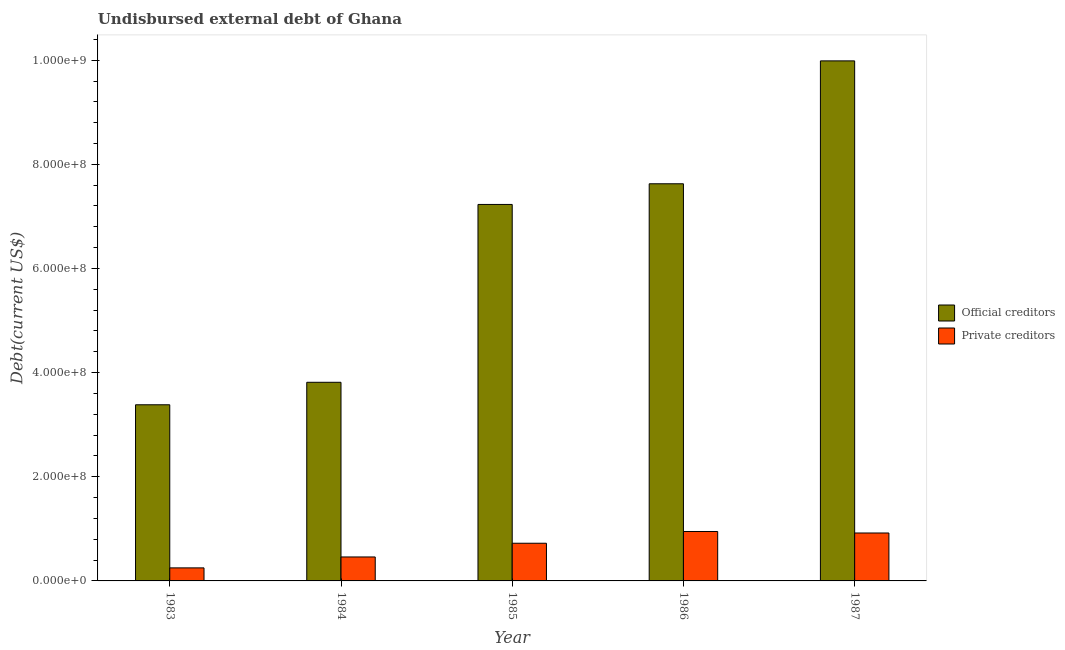How many different coloured bars are there?
Your answer should be very brief. 2. Are the number of bars per tick equal to the number of legend labels?
Give a very brief answer. Yes. Are the number of bars on each tick of the X-axis equal?
Offer a very short reply. Yes. How many bars are there on the 2nd tick from the right?
Your answer should be compact. 2. What is the label of the 4th group of bars from the left?
Your response must be concise. 1986. What is the undisbursed external debt of official creditors in 1987?
Your answer should be compact. 9.99e+08. Across all years, what is the maximum undisbursed external debt of official creditors?
Give a very brief answer. 9.99e+08. Across all years, what is the minimum undisbursed external debt of private creditors?
Your answer should be very brief. 2.50e+07. In which year was the undisbursed external debt of private creditors minimum?
Make the answer very short. 1983. What is the total undisbursed external debt of private creditors in the graph?
Make the answer very short. 3.30e+08. What is the difference between the undisbursed external debt of private creditors in 1984 and that in 1985?
Your answer should be compact. -2.63e+07. What is the difference between the undisbursed external debt of private creditors in 1987 and the undisbursed external debt of official creditors in 1983?
Your answer should be very brief. 6.70e+07. What is the average undisbursed external debt of official creditors per year?
Give a very brief answer. 6.41e+08. In the year 1983, what is the difference between the undisbursed external debt of private creditors and undisbursed external debt of official creditors?
Provide a succinct answer. 0. In how many years, is the undisbursed external debt of private creditors greater than 440000000 US$?
Offer a very short reply. 0. What is the ratio of the undisbursed external debt of private creditors in 1984 to that in 1987?
Offer a terse response. 0.5. Is the undisbursed external debt of private creditors in 1985 less than that in 1987?
Provide a short and direct response. Yes. What is the difference between the highest and the second highest undisbursed external debt of private creditors?
Give a very brief answer. 2.88e+06. What is the difference between the highest and the lowest undisbursed external debt of official creditors?
Your response must be concise. 6.60e+08. What does the 2nd bar from the left in 1983 represents?
Your response must be concise. Private creditors. What does the 1st bar from the right in 1983 represents?
Make the answer very short. Private creditors. How many years are there in the graph?
Your answer should be compact. 5. Does the graph contain any zero values?
Make the answer very short. No. Where does the legend appear in the graph?
Keep it short and to the point. Center right. How many legend labels are there?
Your response must be concise. 2. How are the legend labels stacked?
Your answer should be very brief. Vertical. What is the title of the graph?
Provide a succinct answer. Undisbursed external debt of Ghana. Does "Canada" appear as one of the legend labels in the graph?
Ensure brevity in your answer.  No. What is the label or title of the Y-axis?
Offer a very short reply. Debt(current US$). What is the Debt(current US$) in Official creditors in 1983?
Ensure brevity in your answer.  3.38e+08. What is the Debt(current US$) in Private creditors in 1983?
Keep it short and to the point. 2.50e+07. What is the Debt(current US$) of Official creditors in 1984?
Provide a short and direct response. 3.81e+08. What is the Debt(current US$) of Private creditors in 1984?
Provide a short and direct response. 4.60e+07. What is the Debt(current US$) in Official creditors in 1985?
Provide a short and direct response. 7.23e+08. What is the Debt(current US$) in Private creditors in 1985?
Provide a short and direct response. 7.24e+07. What is the Debt(current US$) in Official creditors in 1986?
Provide a succinct answer. 7.63e+08. What is the Debt(current US$) in Private creditors in 1986?
Your response must be concise. 9.49e+07. What is the Debt(current US$) of Official creditors in 1987?
Your answer should be compact. 9.99e+08. What is the Debt(current US$) of Private creditors in 1987?
Offer a terse response. 9.20e+07. Across all years, what is the maximum Debt(current US$) of Official creditors?
Provide a succinct answer. 9.99e+08. Across all years, what is the maximum Debt(current US$) in Private creditors?
Offer a very short reply. 9.49e+07. Across all years, what is the minimum Debt(current US$) in Official creditors?
Give a very brief answer. 3.38e+08. Across all years, what is the minimum Debt(current US$) of Private creditors?
Your answer should be very brief. 2.50e+07. What is the total Debt(current US$) of Official creditors in the graph?
Give a very brief answer. 3.20e+09. What is the total Debt(current US$) of Private creditors in the graph?
Your answer should be very brief. 3.30e+08. What is the difference between the Debt(current US$) in Official creditors in 1983 and that in 1984?
Provide a short and direct response. -4.32e+07. What is the difference between the Debt(current US$) in Private creditors in 1983 and that in 1984?
Your answer should be compact. -2.10e+07. What is the difference between the Debt(current US$) of Official creditors in 1983 and that in 1985?
Your answer should be very brief. -3.85e+08. What is the difference between the Debt(current US$) of Private creditors in 1983 and that in 1985?
Give a very brief answer. -4.73e+07. What is the difference between the Debt(current US$) of Official creditors in 1983 and that in 1986?
Your answer should be compact. -4.24e+08. What is the difference between the Debt(current US$) of Private creditors in 1983 and that in 1986?
Your response must be concise. -6.99e+07. What is the difference between the Debt(current US$) in Official creditors in 1983 and that in 1987?
Provide a succinct answer. -6.60e+08. What is the difference between the Debt(current US$) of Private creditors in 1983 and that in 1987?
Make the answer very short. -6.70e+07. What is the difference between the Debt(current US$) in Official creditors in 1984 and that in 1985?
Make the answer very short. -3.42e+08. What is the difference between the Debt(current US$) in Private creditors in 1984 and that in 1985?
Provide a short and direct response. -2.63e+07. What is the difference between the Debt(current US$) in Official creditors in 1984 and that in 1986?
Your answer should be compact. -3.81e+08. What is the difference between the Debt(current US$) of Private creditors in 1984 and that in 1986?
Offer a terse response. -4.89e+07. What is the difference between the Debt(current US$) of Official creditors in 1984 and that in 1987?
Offer a terse response. -6.17e+08. What is the difference between the Debt(current US$) of Private creditors in 1984 and that in 1987?
Offer a very short reply. -4.60e+07. What is the difference between the Debt(current US$) in Official creditors in 1985 and that in 1986?
Keep it short and to the point. -3.97e+07. What is the difference between the Debt(current US$) of Private creditors in 1985 and that in 1986?
Ensure brevity in your answer.  -2.26e+07. What is the difference between the Debt(current US$) in Official creditors in 1985 and that in 1987?
Provide a succinct answer. -2.76e+08. What is the difference between the Debt(current US$) in Private creditors in 1985 and that in 1987?
Offer a terse response. -1.97e+07. What is the difference between the Debt(current US$) of Official creditors in 1986 and that in 1987?
Offer a terse response. -2.36e+08. What is the difference between the Debt(current US$) in Private creditors in 1986 and that in 1987?
Keep it short and to the point. 2.88e+06. What is the difference between the Debt(current US$) in Official creditors in 1983 and the Debt(current US$) in Private creditors in 1984?
Provide a succinct answer. 2.92e+08. What is the difference between the Debt(current US$) of Official creditors in 1983 and the Debt(current US$) of Private creditors in 1985?
Your response must be concise. 2.66e+08. What is the difference between the Debt(current US$) of Official creditors in 1983 and the Debt(current US$) of Private creditors in 1986?
Provide a short and direct response. 2.43e+08. What is the difference between the Debt(current US$) in Official creditors in 1983 and the Debt(current US$) in Private creditors in 1987?
Give a very brief answer. 2.46e+08. What is the difference between the Debt(current US$) in Official creditors in 1984 and the Debt(current US$) in Private creditors in 1985?
Give a very brief answer. 3.09e+08. What is the difference between the Debt(current US$) in Official creditors in 1984 and the Debt(current US$) in Private creditors in 1986?
Offer a very short reply. 2.87e+08. What is the difference between the Debt(current US$) of Official creditors in 1984 and the Debt(current US$) of Private creditors in 1987?
Give a very brief answer. 2.89e+08. What is the difference between the Debt(current US$) in Official creditors in 1985 and the Debt(current US$) in Private creditors in 1986?
Give a very brief answer. 6.28e+08. What is the difference between the Debt(current US$) in Official creditors in 1985 and the Debt(current US$) in Private creditors in 1987?
Give a very brief answer. 6.31e+08. What is the difference between the Debt(current US$) in Official creditors in 1986 and the Debt(current US$) in Private creditors in 1987?
Offer a very short reply. 6.71e+08. What is the average Debt(current US$) of Official creditors per year?
Give a very brief answer. 6.41e+08. What is the average Debt(current US$) of Private creditors per year?
Provide a short and direct response. 6.61e+07. In the year 1983, what is the difference between the Debt(current US$) in Official creditors and Debt(current US$) in Private creditors?
Your answer should be very brief. 3.13e+08. In the year 1984, what is the difference between the Debt(current US$) in Official creditors and Debt(current US$) in Private creditors?
Your answer should be very brief. 3.35e+08. In the year 1985, what is the difference between the Debt(current US$) of Official creditors and Debt(current US$) of Private creditors?
Offer a terse response. 6.51e+08. In the year 1986, what is the difference between the Debt(current US$) in Official creditors and Debt(current US$) in Private creditors?
Your answer should be very brief. 6.68e+08. In the year 1987, what is the difference between the Debt(current US$) of Official creditors and Debt(current US$) of Private creditors?
Provide a succinct answer. 9.07e+08. What is the ratio of the Debt(current US$) of Official creditors in 1983 to that in 1984?
Your answer should be very brief. 0.89. What is the ratio of the Debt(current US$) in Private creditors in 1983 to that in 1984?
Provide a succinct answer. 0.54. What is the ratio of the Debt(current US$) in Official creditors in 1983 to that in 1985?
Make the answer very short. 0.47. What is the ratio of the Debt(current US$) of Private creditors in 1983 to that in 1985?
Give a very brief answer. 0.35. What is the ratio of the Debt(current US$) of Official creditors in 1983 to that in 1986?
Provide a succinct answer. 0.44. What is the ratio of the Debt(current US$) of Private creditors in 1983 to that in 1986?
Your answer should be compact. 0.26. What is the ratio of the Debt(current US$) in Official creditors in 1983 to that in 1987?
Offer a very short reply. 0.34. What is the ratio of the Debt(current US$) in Private creditors in 1983 to that in 1987?
Offer a very short reply. 0.27. What is the ratio of the Debt(current US$) in Official creditors in 1984 to that in 1985?
Your answer should be very brief. 0.53. What is the ratio of the Debt(current US$) in Private creditors in 1984 to that in 1985?
Keep it short and to the point. 0.64. What is the ratio of the Debt(current US$) in Official creditors in 1984 to that in 1986?
Your answer should be very brief. 0.5. What is the ratio of the Debt(current US$) in Private creditors in 1984 to that in 1986?
Your answer should be very brief. 0.48. What is the ratio of the Debt(current US$) in Official creditors in 1984 to that in 1987?
Offer a terse response. 0.38. What is the ratio of the Debt(current US$) in Private creditors in 1984 to that in 1987?
Make the answer very short. 0.5. What is the ratio of the Debt(current US$) in Official creditors in 1985 to that in 1986?
Your answer should be very brief. 0.95. What is the ratio of the Debt(current US$) of Private creditors in 1985 to that in 1986?
Your answer should be very brief. 0.76. What is the ratio of the Debt(current US$) in Official creditors in 1985 to that in 1987?
Provide a short and direct response. 0.72. What is the ratio of the Debt(current US$) of Private creditors in 1985 to that in 1987?
Provide a short and direct response. 0.79. What is the ratio of the Debt(current US$) in Official creditors in 1986 to that in 1987?
Offer a very short reply. 0.76. What is the ratio of the Debt(current US$) of Private creditors in 1986 to that in 1987?
Keep it short and to the point. 1.03. What is the difference between the highest and the second highest Debt(current US$) of Official creditors?
Make the answer very short. 2.36e+08. What is the difference between the highest and the second highest Debt(current US$) in Private creditors?
Your response must be concise. 2.88e+06. What is the difference between the highest and the lowest Debt(current US$) of Official creditors?
Offer a very short reply. 6.60e+08. What is the difference between the highest and the lowest Debt(current US$) in Private creditors?
Give a very brief answer. 6.99e+07. 